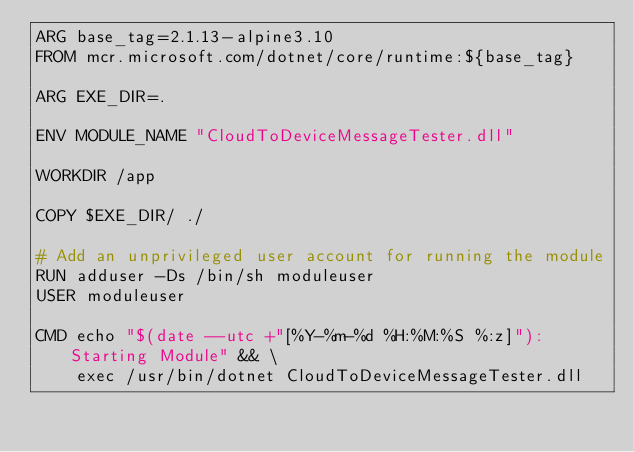<code> <loc_0><loc_0><loc_500><loc_500><_Dockerfile_>ARG base_tag=2.1.13-alpine3.10
FROM mcr.microsoft.com/dotnet/core/runtime:${base_tag}

ARG EXE_DIR=.

ENV MODULE_NAME "CloudToDeviceMessageTester.dll"

WORKDIR /app

COPY $EXE_DIR/ ./

# Add an unprivileged user account for running the module
RUN adduser -Ds /bin/sh moduleuser 
USER moduleuser

CMD echo "$(date --utc +"[%Y-%m-%d %H:%M:%S %:z]"): Starting Module" && \
    exec /usr/bin/dotnet CloudToDeviceMessageTester.dll
</code> 